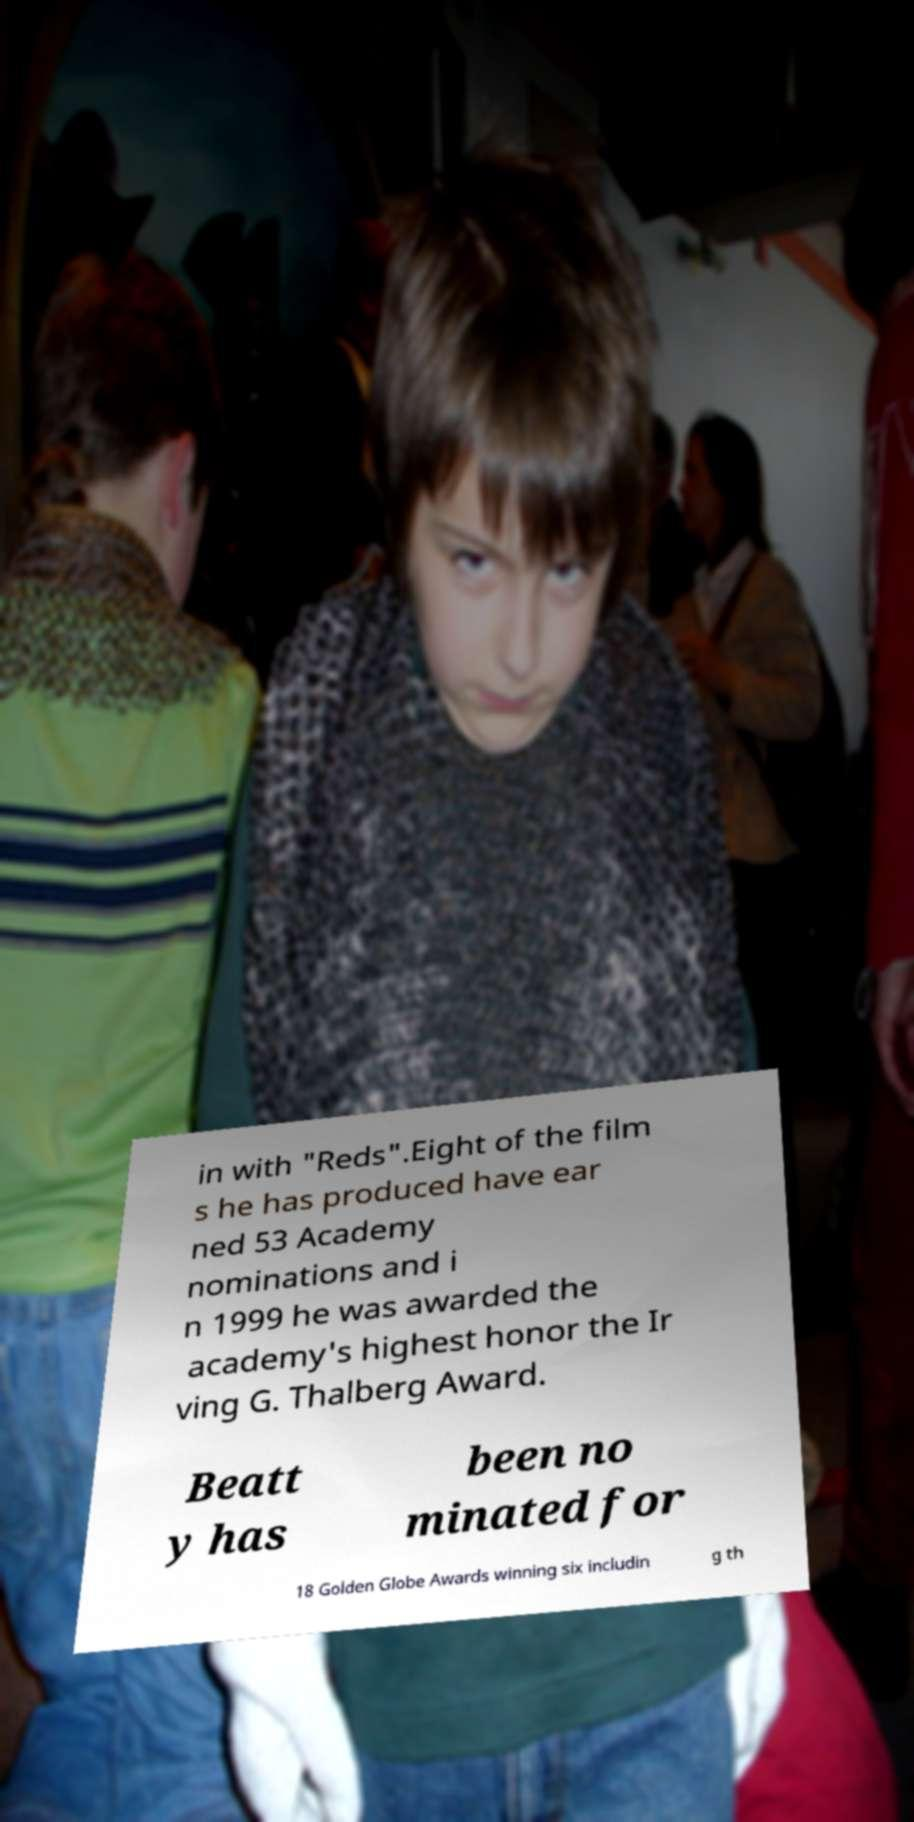For documentation purposes, I need the text within this image transcribed. Could you provide that? in with "Reds".Eight of the film s he has produced have ear ned 53 Academy nominations and i n 1999 he was awarded the academy's highest honor the Ir ving G. Thalberg Award. Beatt y has been no minated for 18 Golden Globe Awards winning six includin g th 